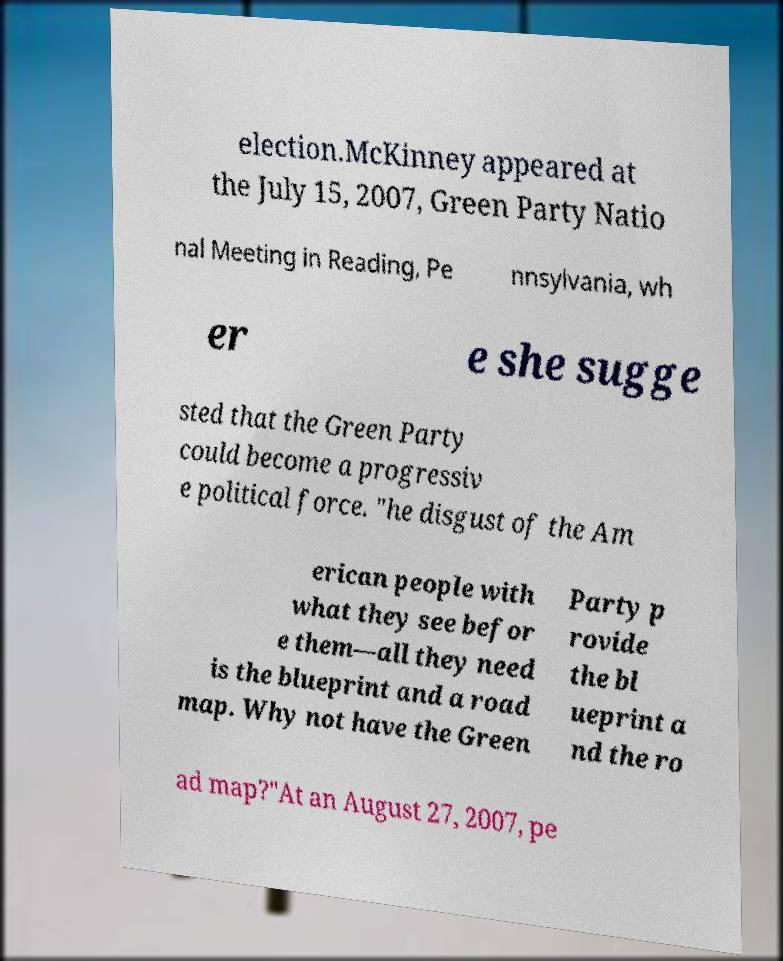What messages or text are displayed in this image? I need them in a readable, typed format. election.McKinney appeared at the July 15, 2007, Green Party Natio nal Meeting in Reading, Pe nnsylvania, wh er e she sugge sted that the Green Party could become a progressiv e political force. "he disgust of the Am erican people with what they see befor e them—all they need is the blueprint and a road map. Why not have the Green Party p rovide the bl ueprint a nd the ro ad map?"At an August 27, 2007, pe 